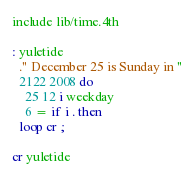Convert code to text. <code><loc_0><loc_0><loc_500><loc_500><_Forth_>include lib/time.4th

: yuletide
  ." December 25 is Sunday in "
  2122 2008 do
    25 12 i weekday
    6 = if i . then
  loop cr ;

cr yuletide
</code> 